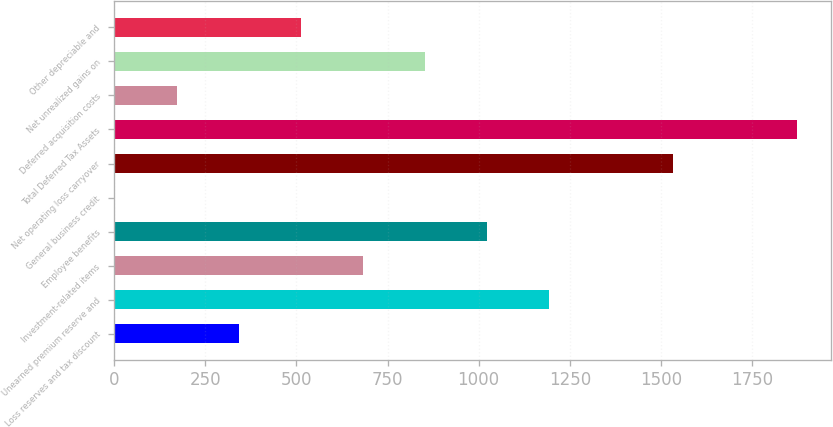Convert chart to OTSL. <chart><loc_0><loc_0><loc_500><loc_500><bar_chart><fcel>Loss reserves and tax discount<fcel>Unearned premium reserve and<fcel>Investment-related items<fcel>Employee benefits<fcel>General business credit<fcel>Net operating loss carryover<fcel>Total Deferred Tax Assets<fcel>Deferred acquisition costs<fcel>Net unrealized gains on<fcel>Other depreciable and<nl><fcel>343<fcel>1193<fcel>683<fcel>1023<fcel>3<fcel>1533<fcel>1873<fcel>173<fcel>853<fcel>513<nl></chart> 